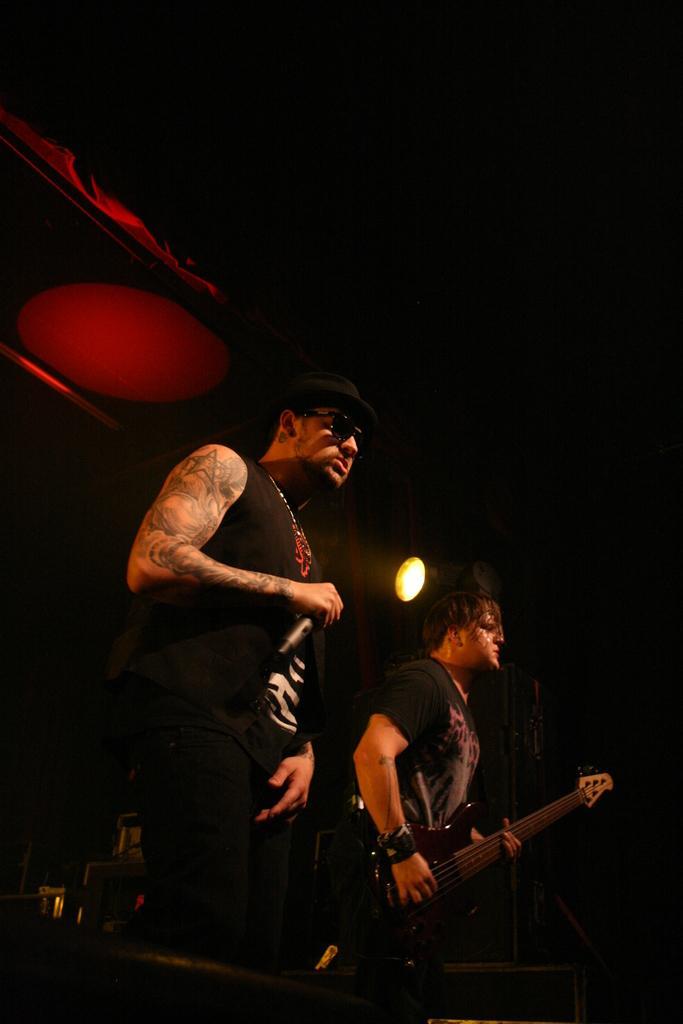Can you describe this image briefly? in this picture we can see two persons in black costume,one person is holding a micro phone another person is holding a guitar. 